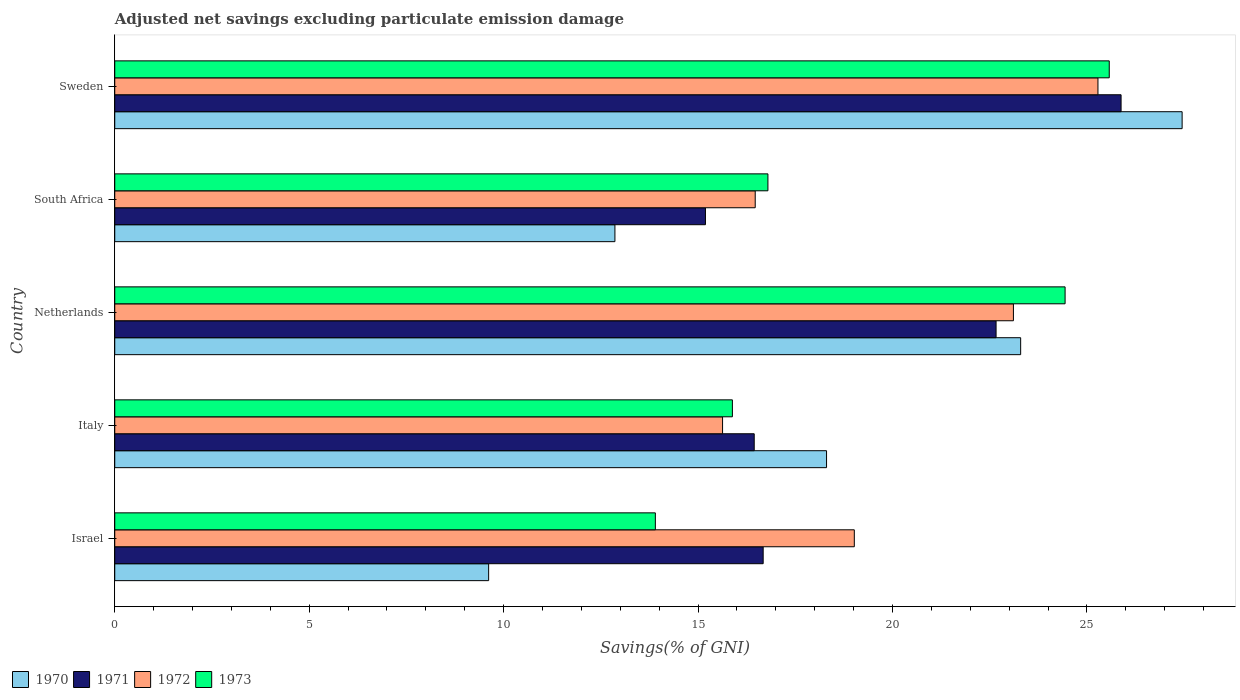Are the number of bars per tick equal to the number of legend labels?
Your answer should be compact. Yes. What is the label of the 4th group of bars from the top?
Provide a succinct answer. Italy. What is the adjusted net savings in 1971 in Israel?
Your response must be concise. 16.67. Across all countries, what is the maximum adjusted net savings in 1972?
Offer a terse response. 25.28. Across all countries, what is the minimum adjusted net savings in 1972?
Your answer should be very brief. 15.63. In which country was the adjusted net savings in 1970 maximum?
Offer a terse response. Sweden. In which country was the adjusted net savings in 1970 minimum?
Give a very brief answer. Israel. What is the total adjusted net savings in 1973 in the graph?
Your response must be concise. 96.59. What is the difference between the adjusted net savings in 1973 in Israel and that in South Africa?
Provide a short and direct response. -2.89. What is the difference between the adjusted net savings in 1972 in Sweden and the adjusted net savings in 1973 in Netherlands?
Your answer should be compact. 0.85. What is the average adjusted net savings in 1970 per country?
Provide a short and direct response. 18.3. What is the difference between the adjusted net savings in 1973 and adjusted net savings in 1972 in Sweden?
Give a very brief answer. 0.29. In how many countries, is the adjusted net savings in 1970 greater than 10 %?
Your response must be concise. 4. What is the ratio of the adjusted net savings in 1971 in Israel to that in Italy?
Make the answer very short. 1.01. Is the difference between the adjusted net savings in 1973 in Israel and Italy greater than the difference between the adjusted net savings in 1972 in Israel and Italy?
Your answer should be very brief. No. What is the difference between the highest and the second highest adjusted net savings in 1971?
Offer a very short reply. 3.21. What is the difference between the highest and the lowest adjusted net savings in 1971?
Keep it short and to the point. 10.69. Is the sum of the adjusted net savings in 1971 in Israel and Sweden greater than the maximum adjusted net savings in 1970 across all countries?
Keep it short and to the point. Yes. Is it the case that in every country, the sum of the adjusted net savings in 1971 and adjusted net savings in 1972 is greater than the sum of adjusted net savings in 1973 and adjusted net savings in 1970?
Give a very brief answer. No. What does the 3rd bar from the top in Italy represents?
Give a very brief answer. 1971. Is it the case that in every country, the sum of the adjusted net savings in 1970 and adjusted net savings in 1971 is greater than the adjusted net savings in 1972?
Your answer should be compact. Yes. How many bars are there?
Give a very brief answer. 20. How many countries are there in the graph?
Your answer should be compact. 5. What is the difference between two consecutive major ticks on the X-axis?
Keep it short and to the point. 5. Are the values on the major ticks of X-axis written in scientific E-notation?
Give a very brief answer. No. Where does the legend appear in the graph?
Offer a very short reply. Bottom left. How are the legend labels stacked?
Offer a terse response. Horizontal. What is the title of the graph?
Provide a succinct answer. Adjusted net savings excluding particulate emission damage. Does "2007" appear as one of the legend labels in the graph?
Ensure brevity in your answer.  No. What is the label or title of the X-axis?
Your answer should be very brief. Savings(% of GNI). What is the label or title of the Y-axis?
Your answer should be very brief. Country. What is the Savings(% of GNI) in 1970 in Israel?
Offer a very short reply. 9.61. What is the Savings(% of GNI) of 1971 in Israel?
Offer a very short reply. 16.67. What is the Savings(% of GNI) of 1972 in Israel?
Give a very brief answer. 19.02. What is the Savings(% of GNI) of 1973 in Israel?
Offer a terse response. 13.9. What is the Savings(% of GNI) of 1970 in Italy?
Keep it short and to the point. 18.3. What is the Savings(% of GNI) in 1971 in Italy?
Make the answer very short. 16.44. What is the Savings(% of GNI) in 1972 in Italy?
Give a very brief answer. 15.63. What is the Savings(% of GNI) of 1973 in Italy?
Offer a very short reply. 15.88. What is the Savings(% of GNI) in 1970 in Netherlands?
Your answer should be compact. 23.3. What is the Savings(% of GNI) of 1971 in Netherlands?
Your answer should be compact. 22.66. What is the Savings(% of GNI) of 1972 in Netherlands?
Your response must be concise. 23.11. What is the Savings(% of GNI) of 1973 in Netherlands?
Keep it short and to the point. 24.44. What is the Savings(% of GNI) of 1970 in South Africa?
Your answer should be compact. 12.86. What is the Savings(% of GNI) of 1971 in South Africa?
Give a very brief answer. 15.19. What is the Savings(% of GNI) of 1972 in South Africa?
Provide a short and direct response. 16.47. What is the Savings(% of GNI) of 1973 in South Africa?
Ensure brevity in your answer.  16.8. What is the Savings(% of GNI) in 1970 in Sweden?
Offer a terse response. 27.45. What is the Savings(% of GNI) of 1971 in Sweden?
Give a very brief answer. 25.88. What is the Savings(% of GNI) in 1972 in Sweden?
Ensure brevity in your answer.  25.28. What is the Savings(% of GNI) of 1973 in Sweden?
Ensure brevity in your answer.  25.57. Across all countries, what is the maximum Savings(% of GNI) in 1970?
Your answer should be compact. 27.45. Across all countries, what is the maximum Savings(% of GNI) of 1971?
Your answer should be very brief. 25.88. Across all countries, what is the maximum Savings(% of GNI) in 1972?
Offer a terse response. 25.28. Across all countries, what is the maximum Savings(% of GNI) of 1973?
Provide a short and direct response. 25.57. Across all countries, what is the minimum Savings(% of GNI) of 1970?
Your response must be concise. 9.61. Across all countries, what is the minimum Savings(% of GNI) of 1971?
Offer a terse response. 15.19. Across all countries, what is the minimum Savings(% of GNI) in 1972?
Your answer should be very brief. 15.63. Across all countries, what is the minimum Savings(% of GNI) in 1973?
Your answer should be very brief. 13.9. What is the total Savings(% of GNI) of 1970 in the graph?
Give a very brief answer. 91.52. What is the total Savings(% of GNI) in 1971 in the graph?
Provide a short and direct response. 96.85. What is the total Savings(% of GNI) of 1972 in the graph?
Your answer should be compact. 99.51. What is the total Savings(% of GNI) in 1973 in the graph?
Offer a very short reply. 96.59. What is the difference between the Savings(% of GNI) of 1970 in Israel and that in Italy?
Your answer should be compact. -8.69. What is the difference between the Savings(% of GNI) of 1971 in Israel and that in Italy?
Ensure brevity in your answer.  0.23. What is the difference between the Savings(% of GNI) in 1972 in Israel and that in Italy?
Make the answer very short. 3.39. What is the difference between the Savings(% of GNI) of 1973 in Israel and that in Italy?
Offer a terse response. -1.98. What is the difference between the Savings(% of GNI) of 1970 in Israel and that in Netherlands?
Give a very brief answer. -13.68. What is the difference between the Savings(% of GNI) in 1971 in Israel and that in Netherlands?
Offer a terse response. -5.99. What is the difference between the Savings(% of GNI) in 1972 in Israel and that in Netherlands?
Ensure brevity in your answer.  -4.09. What is the difference between the Savings(% of GNI) of 1973 in Israel and that in Netherlands?
Provide a short and direct response. -10.54. What is the difference between the Savings(% of GNI) in 1970 in Israel and that in South Africa?
Give a very brief answer. -3.25. What is the difference between the Savings(% of GNI) in 1971 in Israel and that in South Africa?
Your answer should be very brief. 1.48. What is the difference between the Savings(% of GNI) of 1972 in Israel and that in South Africa?
Give a very brief answer. 2.55. What is the difference between the Savings(% of GNI) of 1973 in Israel and that in South Africa?
Provide a succinct answer. -2.89. What is the difference between the Savings(% of GNI) of 1970 in Israel and that in Sweden?
Offer a terse response. -17.83. What is the difference between the Savings(% of GNI) of 1971 in Israel and that in Sweden?
Your response must be concise. -9.2. What is the difference between the Savings(% of GNI) in 1972 in Israel and that in Sweden?
Offer a terse response. -6.27. What is the difference between the Savings(% of GNI) of 1973 in Israel and that in Sweden?
Ensure brevity in your answer.  -11.67. What is the difference between the Savings(% of GNI) of 1970 in Italy and that in Netherlands?
Provide a short and direct response. -4.99. What is the difference between the Savings(% of GNI) of 1971 in Italy and that in Netherlands?
Offer a very short reply. -6.22. What is the difference between the Savings(% of GNI) of 1972 in Italy and that in Netherlands?
Provide a succinct answer. -7.48. What is the difference between the Savings(% of GNI) in 1973 in Italy and that in Netherlands?
Make the answer very short. -8.56. What is the difference between the Savings(% of GNI) of 1970 in Italy and that in South Africa?
Your response must be concise. 5.44. What is the difference between the Savings(% of GNI) of 1971 in Italy and that in South Africa?
Offer a very short reply. 1.25. What is the difference between the Savings(% of GNI) of 1972 in Italy and that in South Africa?
Ensure brevity in your answer.  -0.84. What is the difference between the Savings(% of GNI) in 1973 in Italy and that in South Africa?
Offer a terse response. -0.91. What is the difference between the Savings(% of GNI) in 1970 in Italy and that in Sweden?
Make the answer very short. -9.14. What is the difference between the Savings(% of GNI) in 1971 in Italy and that in Sweden?
Your response must be concise. -9.43. What is the difference between the Savings(% of GNI) in 1972 in Italy and that in Sweden?
Keep it short and to the point. -9.65. What is the difference between the Savings(% of GNI) in 1973 in Italy and that in Sweden?
Your answer should be very brief. -9.69. What is the difference between the Savings(% of GNI) of 1970 in Netherlands and that in South Africa?
Offer a terse response. 10.43. What is the difference between the Savings(% of GNI) in 1971 in Netherlands and that in South Africa?
Ensure brevity in your answer.  7.47. What is the difference between the Savings(% of GNI) in 1972 in Netherlands and that in South Africa?
Make the answer very short. 6.64. What is the difference between the Savings(% of GNI) in 1973 in Netherlands and that in South Africa?
Make the answer very short. 7.64. What is the difference between the Savings(% of GNI) of 1970 in Netherlands and that in Sweden?
Your answer should be very brief. -4.15. What is the difference between the Savings(% of GNI) of 1971 in Netherlands and that in Sweden?
Your answer should be compact. -3.21. What is the difference between the Savings(% of GNI) in 1972 in Netherlands and that in Sweden?
Your answer should be very brief. -2.17. What is the difference between the Savings(% of GNI) in 1973 in Netherlands and that in Sweden?
Ensure brevity in your answer.  -1.14. What is the difference between the Savings(% of GNI) in 1970 in South Africa and that in Sweden?
Offer a terse response. -14.59. What is the difference between the Savings(% of GNI) in 1971 in South Africa and that in Sweden?
Give a very brief answer. -10.69. What is the difference between the Savings(% of GNI) in 1972 in South Africa and that in Sweden?
Your answer should be very brief. -8.81. What is the difference between the Savings(% of GNI) in 1973 in South Africa and that in Sweden?
Provide a short and direct response. -8.78. What is the difference between the Savings(% of GNI) in 1970 in Israel and the Savings(% of GNI) in 1971 in Italy?
Offer a very short reply. -6.83. What is the difference between the Savings(% of GNI) in 1970 in Israel and the Savings(% of GNI) in 1972 in Italy?
Offer a very short reply. -6.02. What is the difference between the Savings(% of GNI) of 1970 in Israel and the Savings(% of GNI) of 1973 in Italy?
Your answer should be compact. -6.27. What is the difference between the Savings(% of GNI) of 1971 in Israel and the Savings(% of GNI) of 1972 in Italy?
Keep it short and to the point. 1.04. What is the difference between the Savings(% of GNI) of 1971 in Israel and the Savings(% of GNI) of 1973 in Italy?
Your response must be concise. 0.79. What is the difference between the Savings(% of GNI) in 1972 in Israel and the Savings(% of GNI) in 1973 in Italy?
Ensure brevity in your answer.  3.14. What is the difference between the Savings(% of GNI) of 1970 in Israel and the Savings(% of GNI) of 1971 in Netherlands?
Keep it short and to the point. -13.05. What is the difference between the Savings(% of GNI) in 1970 in Israel and the Savings(% of GNI) in 1972 in Netherlands?
Keep it short and to the point. -13.49. What is the difference between the Savings(% of GNI) in 1970 in Israel and the Savings(% of GNI) in 1973 in Netherlands?
Ensure brevity in your answer.  -14.82. What is the difference between the Savings(% of GNI) in 1971 in Israel and the Savings(% of GNI) in 1972 in Netherlands?
Offer a terse response. -6.44. What is the difference between the Savings(% of GNI) of 1971 in Israel and the Savings(% of GNI) of 1973 in Netherlands?
Your answer should be compact. -7.76. What is the difference between the Savings(% of GNI) of 1972 in Israel and the Savings(% of GNI) of 1973 in Netherlands?
Your answer should be compact. -5.42. What is the difference between the Savings(% of GNI) in 1970 in Israel and the Savings(% of GNI) in 1971 in South Africa?
Offer a very short reply. -5.58. What is the difference between the Savings(% of GNI) in 1970 in Israel and the Savings(% of GNI) in 1972 in South Africa?
Give a very brief answer. -6.86. What is the difference between the Savings(% of GNI) of 1970 in Israel and the Savings(% of GNI) of 1973 in South Africa?
Ensure brevity in your answer.  -7.18. What is the difference between the Savings(% of GNI) of 1971 in Israel and the Savings(% of GNI) of 1972 in South Africa?
Provide a succinct answer. 0.2. What is the difference between the Savings(% of GNI) of 1971 in Israel and the Savings(% of GNI) of 1973 in South Africa?
Your answer should be compact. -0.12. What is the difference between the Savings(% of GNI) in 1972 in Israel and the Savings(% of GNI) in 1973 in South Africa?
Your answer should be compact. 2.22. What is the difference between the Savings(% of GNI) in 1970 in Israel and the Savings(% of GNI) in 1971 in Sweden?
Your answer should be very brief. -16.26. What is the difference between the Savings(% of GNI) of 1970 in Israel and the Savings(% of GNI) of 1972 in Sweden?
Provide a short and direct response. -15.67. What is the difference between the Savings(% of GNI) of 1970 in Israel and the Savings(% of GNI) of 1973 in Sweden?
Keep it short and to the point. -15.96. What is the difference between the Savings(% of GNI) of 1971 in Israel and the Savings(% of GNI) of 1972 in Sweden?
Offer a very short reply. -8.61. What is the difference between the Savings(% of GNI) in 1971 in Israel and the Savings(% of GNI) in 1973 in Sweden?
Give a very brief answer. -8.9. What is the difference between the Savings(% of GNI) of 1972 in Israel and the Savings(% of GNI) of 1973 in Sweden?
Ensure brevity in your answer.  -6.56. What is the difference between the Savings(% of GNI) in 1970 in Italy and the Savings(% of GNI) in 1971 in Netherlands?
Ensure brevity in your answer.  -4.36. What is the difference between the Savings(% of GNI) in 1970 in Italy and the Savings(% of GNI) in 1972 in Netherlands?
Provide a succinct answer. -4.81. What is the difference between the Savings(% of GNI) of 1970 in Italy and the Savings(% of GNI) of 1973 in Netherlands?
Provide a succinct answer. -6.13. What is the difference between the Savings(% of GNI) of 1971 in Italy and the Savings(% of GNI) of 1972 in Netherlands?
Give a very brief answer. -6.67. What is the difference between the Savings(% of GNI) of 1971 in Italy and the Savings(% of GNI) of 1973 in Netherlands?
Make the answer very short. -7.99. What is the difference between the Savings(% of GNI) in 1972 in Italy and the Savings(% of GNI) in 1973 in Netherlands?
Provide a short and direct response. -8.81. What is the difference between the Savings(% of GNI) in 1970 in Italy and the Savings(% of GNI) in 1971 in South Africa?
Ensure brevity in your answer.  3.11. What is the difference between the Savings(% of GNI) in 1970 in Italy and the Savings(% of GNI) in 1972 in South Africa?
Provide a succinct answer. 1.83. What is the difference between the Savings(% of GNI) of 1970 in Italy and the Savings(% of GNI) of 1973 in South Africa?
Your answer should be compact. 1.51. What is the difference between the Savings(% of GNI) of 1971 in Italy and the Savings(% of GNI) of 1972 in South Africa?
Offer a very short reply. -0.03. What is the difference between the Savings(% of GNI) in 1971 in Italy and the Savings(% of GNI) in 1973 in South Africa?
Your answer should be very brief. -0.35. What is the difference between the Savings(% of GNI) of 1972 in Italy and the Savings(% of GNI) of 1973 in South Africa?
Keep it short and to the point. -1.17. What is the difference between the Savings(% of GNI) of 1970 in Italy and the Savings(% of GNI) of 1971 in Sweden?
Provide a succinct answer. -7.57. What is the difference between the Savings(% of GNI) of 1970 in Italy and the Savings(% of GNI) of 1972 in Sweden?
Provide a short and direct response. -6.98. What is the difference between the Savings(% of GNI) of 1970 in Italy and the Savings(% of GNI) of 1973 in Sweden?
Your answer should be very brief. -7.27. What is the difference between the Savings(% of GNI) in 1971 in Italy and the Savings(% of GNI) in 1972 in Sweden?
Make the answer very short. -8.84. What is the difference between the Savings(% of GNI) of 1971 in Italy and the Savings(% of GNI) of 1973 in Sweden?
Make the answer very short. -9.13. What is the difference between the Savings(% of GNI) of 1972 in Italy and the Savings(% of GNI) of 1973 in Sweden?
Ensure brevity in your answer.  -9.94. What is the difference between the Savings(% of GNI) of 1970 in Netherlands and the Savings(% of GNI) of 1971 in South Africa?
Make the answer very short. 8.11. What is the difference between the Savings(% of GNI) in 1970 in Netherlands and the Savings(% of GNI) in 1972 in South Africa?
Your answer should be very brief. 6.83. What is the difference between the Savings(% of GNI) in 1970 in Netherlands and the Savings(% of GNI) in 1973 in South Africa?
Offer a very short reply. 6.5. What is the difference between the Savings(% of GNI) of 1971 in Netherlands and the Savings(% of GNI) of 1972 in South Africa?
Offer a very short reply. 6.19. What is the difference between the Savings(% of GNI) in 1971 in Netherlands and the Savings(% of GNI) in 1973 in South Africa?
Provide a short and direct response. 5.87. What is the difference between the Savings(% of GNI) in 1972 in Netherlands and the Savings(% of GNI) in 1973 in South Africa?
Your answer should be very brief. 6.31. What is the difference between the Savings(% of GNI) in 1970 in Netherlands and the Savings(% of GNI) in 1971 in Sweden?
Offer a terse response. -2.58. What is the difference between the Savings(% of GNI) in 1970 in Netherlands and the Savings(% of GNI) in 1972 in Sweden?
Keep it short and to the point. -1.99. What is the difference between the Savings(% of GNI) of 1970 in Netherlands and the Savings(% of GNI) of 1973 in Sweden?
Give a very brief answer. -2.28. What is the difference between the Savings(% of GNI) in 1971 in Netherlands and the Savings(% of GNI) in 1972 in Sweden?
Provide a succinct answer. -2.62. What is the difference between the Savings(% of GNI) in 1971 in Netherlands and the Savings(% of GNI) in 1973 in Sweden?
Your answer should be very brief. -2.91. What is the difference between the Savings(% of GNI) of 1972 in Netherlands and the Savings(% of GNI) of 1973 in Sweden?
Ensure brevity in your answer.  -2.46. What is the difference between the Savings(% of GNI) in 1970 in South Africa and the Savings(% of GNI) in 1971 in Sweden?
Give a very brief answer. -13.02. What is the difference between the Savings(% of GNI) of 1970 in South Africa and the Savings(% of GNI) of 1972 in Sweden?
Your answer should be compact. -12.42. What is the difference between the Savings(% of GNI) of 1970 in South Africa and the Savings(% of GNI) of 1973 in Sweden?
Give a very brief answer. -12.71. What is the difference between the Savings(% of GNI) of 1971 in South Africa and the Savings(% of GNI) of 1972 in Sweden?
Provide a succinct answer. -10.09. What is the difference between the Savings(% of GNI) in 1971 in South Africa and the Savings(% of GNI) in 1973 in Sweden?
Offer a very short reply. -10.38. What is the difference between the Savings(% of GNI) of 1972 in South Africa and the Savings(% of GNI) of 1973 in Sweden?
Ensure brevity in your answer.  -9.1. What is the average Savings(% of GNI) of 1970 per country?
Offer a very short reply. 18.3. What is the average Savings(% of GNI) in 1971 per country?
Provide a short and direct response. 19.37. What is the average Savings(% of GNI) of 1972 per country?
Keep it short and to the point. 19.9. What is the average Savings(% of GNI) in 1973 per country?
Your answer should be compact. 19.32. What is the difference between the Savings(% of GNI) of 1970 and Savings(% of GNI) of 1971 in Israel?
Provide a short and direct response. -7.06. What is the difference between the Savings(% of GNI) in 1970 and Savings(% of GNI) in 1972 in Israel?
Ensure brevity in your answer.  -9.4. What is the difference between the Savings(% of GNI) of 1970 and Savings(% of GNI) of 1973 in Israel?
Provide a succinct answer. -4.29. What is the difference between the Savings(% of GNI) of 1971 and Savings(% of GNI) of 1972 in Israel?
Offer a very short reply. -2.34. What is the difference between the Savings(% of GNI) of 1971 and Savings(% of GNI) of 1973 in Israel?
Offer a very short reply. 2.77. What is the difference between the Savings(% of GNI) of 1972 and Savings(% of GNI) of 1973 in Israel?
Provide a succinct answer. 5.12. What is the difference between the Savings(% of GNI) of 1970 and Savings(% of GNI) of 1971 in Italy?
Give a very brief answer. 1.86. What is the difference between the Savings(% of GNI) in 1970 and Savings(% of GNI) in 1972 in Italy?
Make the answer very short. 2.67. What is the difference between the Savings(% of GNI) of 1970 and Savings(% of GNI) of 1973 in Italy?
Your answer should be compact. 2.42. What is the difference between the Savings(% of GNI) in 1971 and Savings(% of GNI) in 1972 in Italy?
Your answer should be very brief. 0.81. What is the difference between the Savings(% of GNI) of 1971 and Savings(% of GNI) of 1973 in Italy?
Provide a succinct answer. 0.56. What is the difference between the Savings(% of GNI) in 1972 and Savings(% of GNI) in 1973 in Italy?
Make the answer very short. -0.25. What is the difference between the Savings(% of GNI) in 1970 and Savings(% of GNI) in 1971 in Netherlands?
Provide a short and direct response. 0.63. What is the difference between the Savings(% of GNI) of 1970 and Savings(% of GNI) of 1972 in Netherlands?
Keep it short and to the point. 0.19. What is the difference between the Savings(% of GNI) in 1970 and Savings(% of GNI) in 1973 in Netherlands?
Your response must be concise. -1.14. What is the difference between the Savings(% of GNI) in 1971 and Savings(% of GNI) in 1972 in Netherlands?
Your response must be concise. -0.45. What is the difference between the Savings(% of GNI) of 1971 and Savings(% of GNI) of 1973 in Netherlands?
Your response must be concise. -1.77. What is the difference between the Savings(% of GNI) of 1972 and Savings(% of GNI) of 1973 in Netherlands?
Ensure brevity in your answer.  -1.33. What is the difference between the Savings(% of GNI) in 1970 and Savings(% of GNI) in 1971 in South Africa?
Give a very brief answer. -2.33. What is the difference between the Savings(% of GNI) of 1970 and Savings(% of GNI) of 1972 in South Africa?
Keep it short and to the point. -3.61. What is the difference between the Savings(% of GNI) in 1970 and Savings(% of GNI) in 1973 in South Africa?
Make the answer very short. -3.93. What is the difference between the Savings(% of GNI) in 1971 and Savings(% of GNI) in 1972 in South Africa?
Make the answer very short. -1.28. What is the difference between the Savings(% of GNI) in 1971 and Savings(% of GNI) in 1973 in South Africa?
Keep it short and to the point. -1.61. What is the difference between the Savings(% of GNI) of 1972 and Savings(% of GNI) of 1973 in South Africa?
Your response must be concise. -0.33. What is the difference between the Savings(% of GNI) in 1970 and Savings(% of GNI) in 1971 in Sweden?
Provide a short and direct response. 1.57. What is the difference between the Savings(% of GNI) of 1970 and Savings(% of GNI) of 1972 in Sweden?
Your response must be concise. 2.16. What is the difference between the Savings(% of GNI) of 1970 and Savings(% of GNI) of 1973 in Sweden?
Your answer should be very brief. 1.87. What is the difference between the Savings(% of GNI) of 1971 and Savings(% of GNI) of 1972 in Sweden?
Offer a very short reply. 0.59. What is the difference between the Savings(% of GNI) of 1971 and Savings(% of GNI) of 1973 in Sweden?
Offer a very short reply. 0.3. What is the difference between the Savings(% of GNI) in 1972 and Savings(% of GNI) in 1973 in Sweden?
Your answer should be very brief. -0.29. What is the ratio of the Savings(% of GNI) in 1970 in Israel to that in Italy?
Provide a short and direct response. 0.53. What is the ratio of the Savings(% of GNI) of 1971 in Israel to that in Italy?
Give a very brief answer. 1.01. What is the ratio of the Savings(% of GNI) in 1972 in Israel to that in Italy?
Offer a terse response. 1.22. What is the ratio of the Savings(% of GNI) in 1973 in Israel to that in Italy?
Your response must be concise. 0.88. What is the ratio of the Savings(% of GNI) in 1970 in Israel to that in Netherlands?
Offer a terse response. 0.41. What is the ratio of the Savings(% of GNI) in 1971 in Israel to that in Netherlands?
Offer a terse response. 0.74. What is the ratio of the Savings(% of GNI) in 1972 in Israel to that in Netherlands?
Your answer should be very brief. 0.82. What is the ratio of the Savings(% of GNI) in 1973 in Israel to that in Netherlands?
Ensure brevity in your answer.  0.57. What is the ratio of the Savings(% of GNI) of 1970 in Israel to that in South Africa?
Offer a very short reply. 0.75. What is the ratio of the Savings(% of GNI) of 1971 in Israel to that in South Africa?
Your answer should be very brief. 1.1. What is the ratio of the Savings(% of GNI) of 1972 in Israel to that in South Africa?
Your answer should be compact. 1.15. What is the ratio of the Savings(% of GNI) in 1973 in Israel to that in South Africa?
Make the answer very short. 0.83. What is the ratio of the Savings(% of GNI) of 1970 in Israel to that in Sweden?
Make the answer very short. 0.35. What is the ratio of the Savings(% of GNI) of 1971 in Israel to that in Sweden?
Your answer should be very brief. 0.64. What is the ratio of the Savings(% of GNI) of 1972 in Israel to that in Sweden?
Your answer should be compact. 0.75. What is the ratio of the Savings(% of GNI) in 1973 in Israel to that in Sweden?
Give a very brief answer. 0.54. What is the ratio of the Savings(% of GNI) of 1970 in Italy to that in Netherlands?
Offer a very short reply. 0.79. What is the ratio of the Savings(% of GNI) in 1971 in Italy to that in Netherlands?
Make the answer very short. 0.73. What is the ratio of the Savings(% of GNI) in 1972 in Italy to that in Netherlands?
Keep it short and to the point. 0.68. What is the ratio of the Savings(% of GNI) in 1973 in Italy to that in Netherlands?
Make the answer very short. 0.65. What is the ratio of the Savings(% of GNI) in 1970 in Italy to that in South Africa?
Your answer should be compact. 1.42. What is the ratio of the Savings(% of GNI) of 1971 in Italy to that in South Africa?
Ensure brevity in your answer.  1.08. What is the ratio of the Savings(% of GNI) of 1972 in Italy to that in South Africa?
Offer a terse response. 0.95. What is the ratio of the Savings(% of GNI) of 1973 in Italy to that in South Africa?
Ensure brevity in your answer.  0.95. What is the ratio of the Savings(% of GNI) in 1970 in Italy to that in Sweden?
Keep it short and to the point. 0.67. What is the ratio of the Savings(% of GNI) in 1971 in Italy to that in Sweden?
Provide a short and direct response. 0.64. What is the ratio of the Savings(% of GNI) in 1972 in Italy to that in Sweden?
Ensure brevity in your answer.  0.62. What is the ratio of the Savings(% of GNI) of 1973 in Italy to that in Sweden?
Offer a very short reply. 0.62. What is the ratio of the Savings(% of GNI) in 1970 in Netherlands to that in South Africa?
Offer a very short reply. 1.81. What is the ratio of the Savings(% of GNI) of 1971 in Netherlands to that in South Africa?
Your answer should be compact. 1.49. What is the ratio of the Savings(% of GNI) of 1972 in Netherlands to that in South Africa?
Provide a succinct answer. 1.4. What is the ratio of the Savings(% of GNI) in 1973 in Netherlands to that in South Africa?
Your response must be concise. 1.46. What is the ratio of the Savings(% of GNI) in 1970 in Netherlands to that in Sweden?
Your response must be concise. 0.85. What is the ratio of the Savings(% of GNI) in 1971 in Netherlands to that in Sweden?
Ensure brevity in your answer.  0.88. What is the ratio of the Savings(% of GNI) in 1972 in Netherlands to that in Sweden?
Your response must be concise. 0.91. What is the ratio of the Savings(% of GNI) in 1973 in Netherlands to that in Sweden?
Give a very brief answer. 0.96. What is the ratio of the Savings(% of GNI) of 1970 in South Africa to that in Sweden?
Give a very brief answer. 0.47. What is the ratio of the Savings(% of GNI) of 1971 in South Africa to that in Sweden?
Make the answer very short. 0.59. What is the ratio of the Savings(% of GNI) in 1972 in South Africa to that in Sweden?
Give a very brief answer. 0.65. What is the ratio of the Savings(% of GNI) of 1973 in South Africa to that in Sweden?
Make the answer very short. 0.66. What is the difference between the highest and the second highest Savings(% of GNI) in 1970?
Your answer should be compact. 4.15. What is the difference between the highest and the second highest Savings(% of GNI) in 1971?
Ensure brevity in your answer.  3.21. What is the difference between the highest and the second highest Savings(% of GNI) of 1972?
Offer a very short reply. 2.17. What is the difference between the highest and the second highest Savings(% of GNI) of 1973?
Offer a very short reply. 1.14. What is the difference between the highest and the lowest Savings(% of GNI) of 1970?
Offer a very short reply. 17.83. What is the difference between the highest and the lowest Savings(% of GNI) of 1971?
Provide a short and direct response. 10.69. What is the difference between the highest and the lowest Savings(% of GNI) of 1972?
Offer a very short reply. 9.65. What is the difference between the highest and the lowest Savings(% of GNI) of 1973?
Provide a short and direct response. 11.67. 